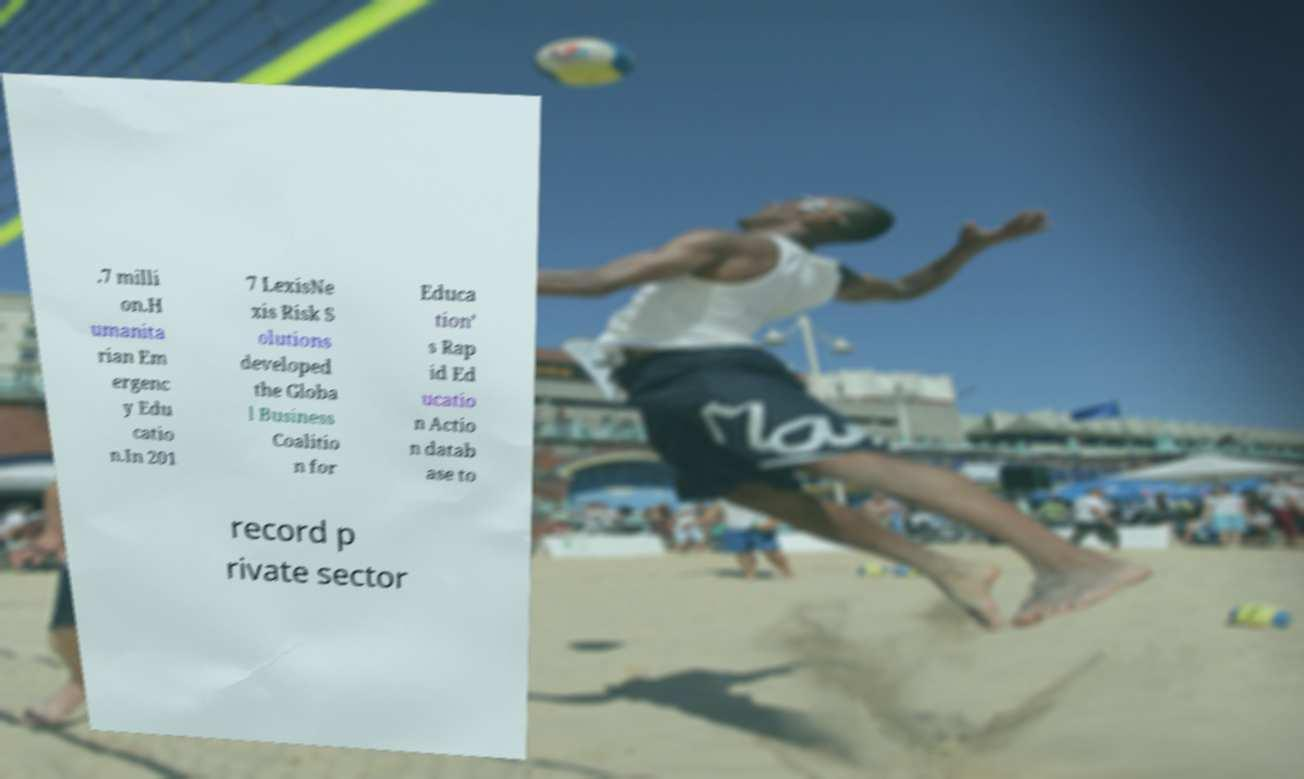For documentation purposes, I need the text within this image transcribed. Could you provide that? .7 milli on.H umanita rian Em ergenc y Edu catio n.In 201 7 LexisNe xis Risk S olutions developed the Globa l Business Coalitio n for Educa tion’ s Rap id Ed ucatio n Actio n datab ase to record p rivate sector 